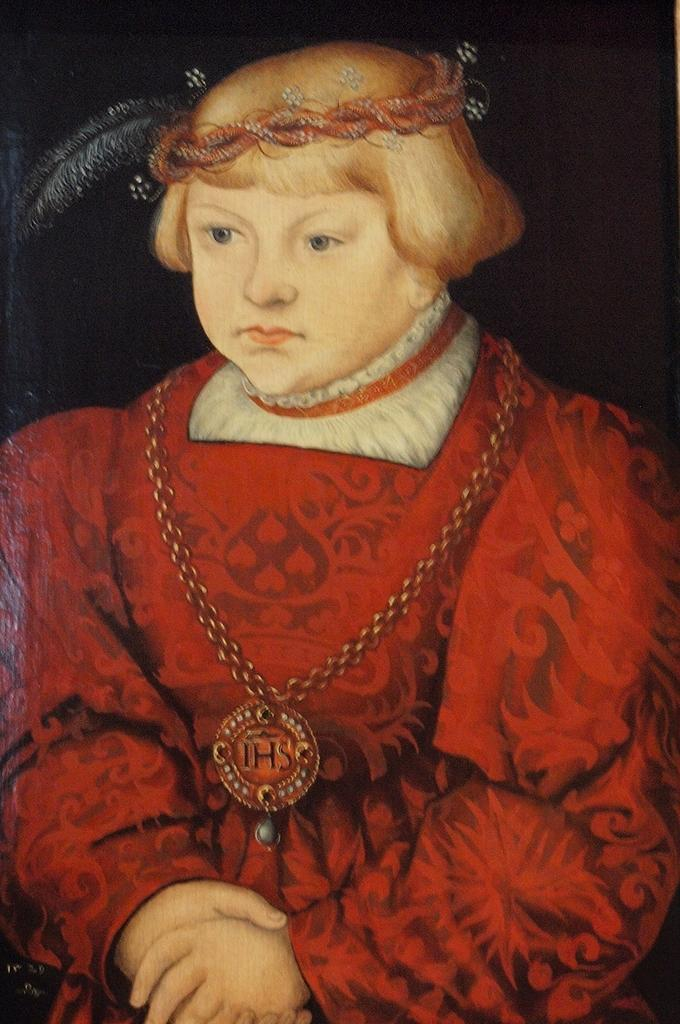What type of artwork is shown in the image? The image is a painting. What is the main subject of the painting? The painting depicts a girl. What is the girl wearing in the painting? The girl is wearing a red dress. What type of jar is the girl holding in the painting? There is no jar present in the painting; the girl is wearing a red dress. Can you describe the feather that is attached to the girl's dress in the painting? There is no feather attached to the girl's dress in the painting; she is simply wearing a red dress. 